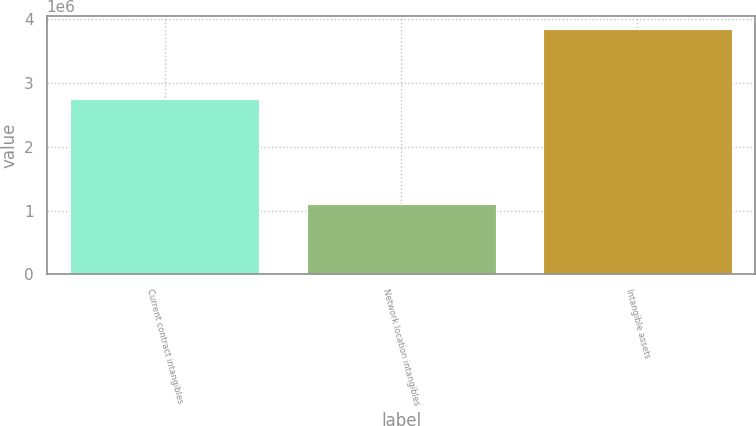Convert chart. <chart><loc_0><loc_0><loc_500><loc_500><bar_chart><fcel>Current contract intangibles<fcel>Network location intangibles<fcel>Intangible assets<nl><fcel>2.74497e+06<fcel>1.10157e+06<fcel>3.84653e+06<nl></chart> 